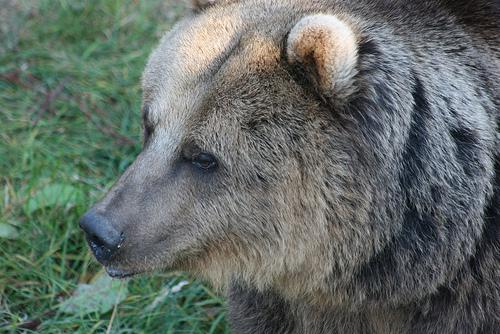Question: what is in the picture?
Choices:
A. A cow.
B. A house.
C. A piano.
D. Dog.
Answer with the letter. Answer: D Question: what is on the ground?
Choices:
A. Dirt.
B. Snow.
C. Grass.
D. Rain.
Answer with the letter. Answer: C Question: how many red collars is the dog wearing?
Choices:
A. None.
B. One.
C. Two.
D. Three.
Answer with the letter. Answer: A 